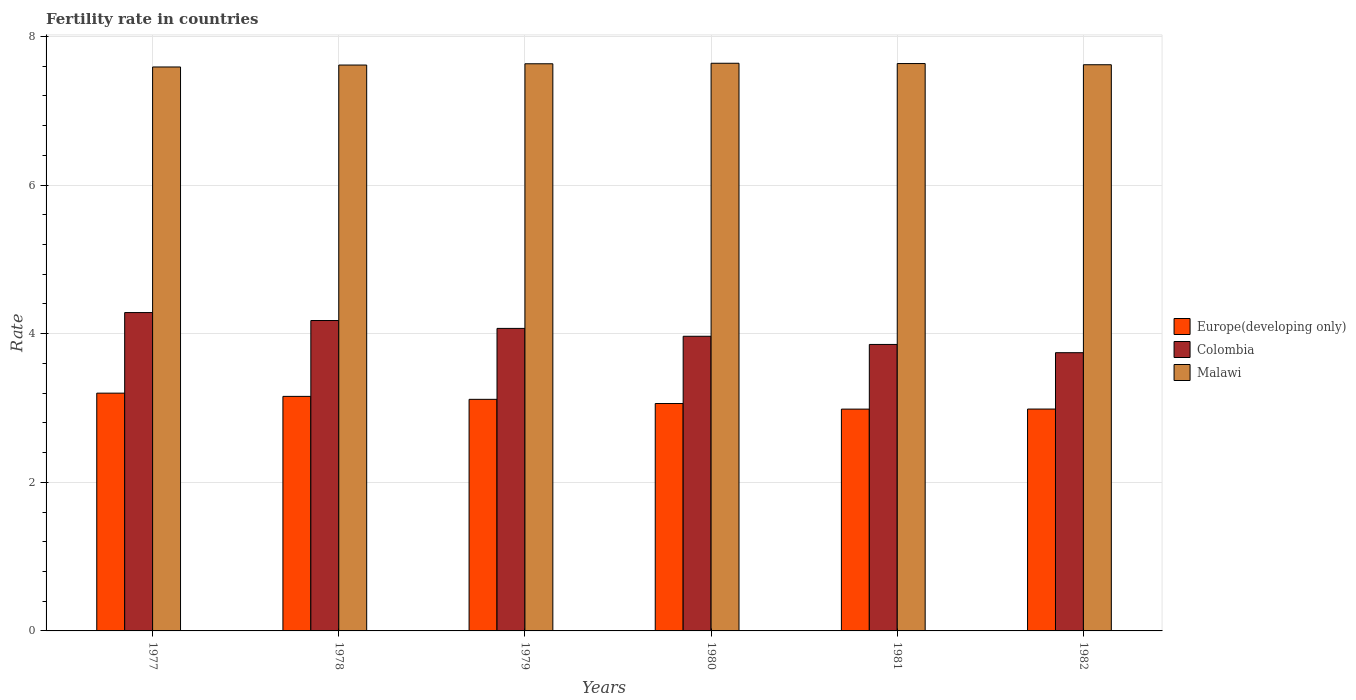Are the number of bars per tick equal to the number of legend labels?
Your answer should be compact. Yes. What is the label of the 3rd group of bars from the left?
Offer a terse response. 1979. What is the fertility rate in Malawi in 1982?
Ensure brevity in your answer.  7.62. Across all years, what is the maximum fertility rate in Europe(developing only)?
Your answer should be compact. 3.2. Across all years, what is the minimum fertility rate in Colombia?
Offer a very short reply. 3.74. In which year was the fertility rate in Europe(developing only) maximum?
Keep it short and to the point. 1977. What is the total fertility rate in Europe(developing only) in the graph?
Keep it short and to the point. 18.5. What is the difference between the fertility rate in Malawi in 1978 and that in 1980?
Keep it short and to the point. -0.02. What is the difference between the fertility rate in Europe(developing only) in 1981 and the fertility rate in Malawi in 1980?
Offer a terse response. -4.65. What is the average fertility rate in Colombia per year?
Your answer should be very brief. 4.02. In the year 1978, what is the difference between the fertility rate in Europe(developing only) and fertility rate in Malawi?
Offer a terse response. -4.46. In how many years, is the fertility rate in Europe(developing only) greater than 7.6?
Make the answer very short. 0. What is the ratio of the fertility rate in Europe(developing only) in 1977 to that in 1981?
Your answer should be very brief. 1.07. Is the fertility rate in Europe(developing only) in 1978 less than that in 1982?
Offer a very short reply. No. Is the difference between the fertility rate in Europe(developing only) in 1977 and 1978 greater than the difference between the fertility rate in Malawi in 1977 and 1978?
Offer a very short reply. Yes. What is the difference between the highest and the second highest fertility rate in Malawi?
Offer a very short reply. 0. What is the difference between the highest and the lowest fertility rate in Colombia?
Provide a short and direct response. 0.54. In how many years, is the fertility rate in Europe(developing only) greater than the average fertility rate in Europe(developing only) taken over all years?
Your answer should be compact. 3. What does the 2nd bar from the right in 1977 represents?
Give a very brief answer. Colombia. Is it the case that in every year, the sum of the fertility rate in Colombia and fertility rate in Europe(developing only) is greater than the fertility rate in Malawi?
Ensure brevity in your answer.  No. What is the difference between two consecutive major ticks on the Y-axis?
Provide a short and direct response. 2. Are the values on the major ticks of Y-axis written in scientific E-notation?
Your answer should be very brief. No. Does the graph contain grids?
Your answer should be very brief. Yes. How many legend labels are there?
Offer a very short reply. 3. How are the legend labels stacked?
Make the answer very short. Vertical. What is the title of the graph?
Ensure brevity in your answer.  Fertility rate in countries. Does "American Samoa" appear as one of the legend labels in the graph?
Offer a terse response. No. What is the label or title of the X-axis?
Provide a succinct answer. Years. What is the label or title of the Y-axis?
Ensure brevity in your answer.  Rate. What is the Rate of Europe(developing only) in 1977?
Your response must be concise. 3.2. What is the Rate in Colombia in 1977?
Provide a short and direct response. 4.28. What is the Rate in Malawi in 1977?
Provide a succinct answer. 7.59. What is the Rate in Europe(developing only) in 1978?
Your answer should be compact. 3.16. What is the Rate of Colombia in 1978?
Offer a very short reply. 4.18. What is the Rate of Malawi in 1978?
Offer a terse response. 7.62. What is the Rate of Europe(developing only) in 1979?
Give a very brief answer. 3.12. What is the Rate in Colombia in 1979?
Make the answer very short. 4.07. What is the Rate of Malawi in 1979?
Your answer should be very brief. 7.63. What is the Rate of Europe(developing only) in 1980?
Offer a terse response. 3.06. What is the Rate of Colombia in 1980?
Offer a very short reply. 3.96. What is the Rate in Malawi in 1980?
Provide a short and direct response. 7.64. What is the Rate of Europe(developing only) in 1981?
Offer a very short reply. 2.98. What is the Rate of Colombia in 1981?
Offer a very short reply. 3.85. What is the Rate of Malawi in 1981?
Your answer should be very brief. 7.63. What is the Rate of Europe(developing only) in 1982?
Your response must be concise. 2.99. What is the Rate in Colombia in 1982?
Make the answer very short. 3.74. What is the Rate in Malawi in 1982?
Give a very brief answer. 7.62. Across all years, what is the maximum Rate of Europe(developing only)?
Offer a terse response. 3.2. Across all years, what is the maximum Rate of Colombia?
Your response must be concise. 4.28. Across all years, what is the maximum Rate in Malawi?
Make the answer very short. 7.64. Across all years, what is the minimum Rate of Europe(developing only)?
Your response must be concise. 2.98. Across all years, what is the minimum Rate in Colombia?
Ensure brevity in your answer.  3.74. Across all years, what is the minimum Rate of Malawi?
Give a very brief answer. 7.59. What is the total Rate of Europe(developing only) in the graph?
Your answer should be compact. 18.5. What is the total Rate in Colombia in the graph?
Ensure brevity in your answer.  24.1. What is the total Rate in Malawi in the graph?
Provide a succinct answer. 45.73. What is the difference between the Rate in Europe(developing only) in 1977 and that in 1978?
Offer a terse response. 0.04. What is the difference between the Rate of Colombia in 1977 and that in 1978?
Offer a very short reply. 0.11. What is the difference between the Rate of Malawi in 1977 and that in 1978?
Offer a terse response. -0.03. What is the difference between the Rate of Europe(developing only) in 1977 and that in 1979?
Ensure brevity in your answer.  0.08. What is the difference between the Rate in Colombia in 1977 and that in 1979?
Keep it short and to the point. 0.21. What is the difference between the Rate of Malawi in 1977 and that in 1979?
Your answer should be compact. -0.04. What is the difference between the Rate of Europe(developing only) in 1977 and that in 1980?
Give a very brief answer. 0.14. What is the difference between the Rate in Colombia in 1977 and that in 1980?
Give a very brief answer. 0.32. What is the difference between the Rate in Europe(developing only) in 1977 and that in 1981?
Your answer should be compact. 0.21. What is the difference between the Rate of Colombia in 1977 and that in 1981?
Keep it short and to the point. 0.43. What is the difference between the Rate in Malawi in 1977 and that in 1981?
Your response must be concise. -0.05. What is the difference between the Rate of Europe(developing only) in 1977 and that in 1982?
Your answer should be very brief. 0.21. What is the difference between the Rate of Colombia in 1977 and that in 1982?
Your response must be concise. 0.54. What is the difference between the Rate in Malawi in 1977 and that in 1982?
Give a very brief answer. -0.03. What is the difference between the Rate of Europe(developing only) in 1978 and that in 1979?
Your answer should be compact. 0.04. What is the difference between the Rate of Colombia in 1978 and that in 1979?
Make the answer very short. 0.11. What is the difference between the Rate of Malawi in 1978 and that in 1979?
Make the answer very short. -0.02. What is the difference between the Rate of Europe(developing only) in 1978 and that in 1980?
Make the answer very short. 0.1. What is the difference between the Rate of Colombia in 1978 and that in 1980?
Provide a short and direct response. 0.21. What is the difference between the Rate of Malawi in 1978 and that in 1980?
Keep it short and to the point. -0.02. What is the difference between the Rate of Europe(developing only) in 1978 and that in 1981?
Offer a terse response. 0.17. What is the difference between the Rate of Colombia in 1978 and that in 1981?
Provide a succinct answer. 0.32. What is the difference between the Rate in Malawi in 1978 and that in 1981?
Offer a very short reply. -0.02. What is the difference between the Rate in Europe(developing only) in 1978 and that in 1982?
Your answer should be compact. 0.17. What is the difference between the Rate of Colombia in 1978 and that in 1982?
Your answer should be compact. 0.43. What is the difference between the Rate of Malawi in 1978 and that in 1982?
Your answer should be compact. -0. What is the difference between the Rate of Europe(developing only) in 1979 and that in 1980?
Your response must be concise. 0.06. What is the difference between the Rate in Colombia in 1979 and that in 1980?
Make the answer very short. 0.11. What is the difference between the Rate in Malawi in 1979 and that in 1980?
Offer a terse response. -0.01. What is the difference between the Rate in Europe(developing only) in 1979 and that in 1981?
Your answer should be compact. 0.13. What is the difference between the Rate in Colombia in 1979 and that in 1981?
Your answer should be compact. 0.22. What is the difference between the Rate of Malawi in 1979 and that in 1981?
Offer a very short reply. -0. What is the difference between the Rate in Europe(developing only) in 1979 and that in 1982?
Your answer should be compact. 0.13. What is the difference between the Rate in Colombia in 1979 and that in 1982?
Your response must be concise. 0.33. What is the difference between the Rate in Malawi in 1979 and that in 1982?
Your response must be concise. 0.01. What is the difference between the Rate of Europe(developing only) in 1980 and that in 1981?
Offer a terse response. 0.08. What is the difference between the Rate in Colombia in 1980 and that in 1981?
Offer a terse response. 0.11. What is the difference between the Rate in Malawi in 1980 and that in 1981?
Give a very brief answer. 0. What is the difference between the Rate in Europe(developing only) in 1980 and that in 1982?
Make the answer very short. 0.07. What is the difference between the Rate of Colombia in 1980 and that in 1982?
Offer a very short reply. 0.22. What is the difference between the Rate in Malawi in 1980 and that in 1982?
Make the answer very short. 0.02. What is the difference between the Rate in Europe(developing only) in 1981 and that in 1982?
Give a very brief answer. -0. What is the difference between the Rate in Colombia in 1981 and that in 1982?
Provide a succinct answer. 0.11. What is the difference between the Rate in Malawi in 1981 and that in 1982?
Your answer should be very brief. 0.02. What is the difference between the Rate of Europe(developing only) in 1977 and the Rate of Colombia in 1978?
Your answer should be compact. -0.98. What is the difference between the Rate in Europe(developing only) in 1977 and the Rate in Malawi in 1978?
Keep it short and to the point. -4.42. What is the difference between the Rate in Colombia in 1977 and the Rate in Malawi in 1978?
Give a very brief answer. -3.33. What is the difference between the Rate in Europe(developing only) in 1977 and the Rate in Colombia in 1979?
Provide a short and direct response. -0.87. What is the difference between the Rate of Europe(developing only) in 1977 and the Rate of Malawi in 1979?
Ensure brevity in your answer.  -4.43. What is the difference between the Rate in Colombia in 1977 and the Rate in Malawi in 1979?
Ensure brevity in your answer.  -3.35. What is the difference between the Rate of Europe(developing only) in 1977 and the Rate of Colombia in 1980?
Offer a very short reply. -0.77. What is the difference between the Rate in Europe(developing only) in 1977 and the Rate in Malawi in 1980?
Your answer should be very brief. -4.44. What is the difference between the Rate in Colombia in 1977 and the Rate in Malawi in 1980?
Keep it short and to the point. -3.35. What is the difference between the Rate in Europe(developing only) in 1977 and the Rate in Colombia in 1981?
Provide a succinct answer. -0.66. What is the difference between the Rate of Europe(developing only) in 1977 and the Rate of Malawi in 1981?
Keep it short and to the point. -4.44. What is the difference between the Rate in Colombia in 1977 and the Rate in Malawi in 1981?
Offer a very short reply. -3.35. What is the difference between the Rate of Europe(developing only) in 1977 and the Rate of Colombia in 1982?
Provide a succinct answer. -0.54. What is the difference between the Rate in Europe(developing only) in 1977 and the Rate in Malawi in 1982?
Offer a terse response. -4.42. What is the difference between the Rate of Colombia in 1977 and the Rate of Malawi in 1982?
Give a very brief answer. -3.33. What is the difference between the Rate in Europe(developing only) in 1978 and the Rate in Colombia in 1979?
Your response must be concise. -0.91. What is the difference between the Rate in Europe(developing only) in 1978 and the Rate in Malawi in 1979?
Give a very brief answer. -4.48. What is the difference between the Rate of Colombia in 1978 and the Rate of Malawi in 1979?
Provide a short and direct response. -3.46. What is the difference between the Rate of Europe(developing only) in 1978 and the Rate of Colombia in 1980?
Offer a terse response. -0.81. What is the difference between the Rate of Europe(developing only) in 1978 and the Rate of Malawi in 1980?
Your response must be concise. -4.48. What is the difference between the Rate in Colombia in 1978 and the Rate in Malawi in 1980?
Keep it short and to the point. -3.46. What is the difference between the Rate in Europe(developing only) in 1978 and the Rate in Colombia in 1981?
Your response must be concise. -0.7. What is the difference between the Rate of Europe(developing only) in 1978 and the Rate of Malawi in 1981?
Offer a very short reply. -4.48. What is the difference between the Rate of Colombia in 1978 and the Rate of Malawi in 1981?
Provide a short and direct response. -3.46. What is the difference between the Rate in Europe(developing only) in 1978 and the Rate in Colombia in 1982?
Offer a terse response. -0.59. What is the difference between the Rate in Europe(developing only) in 1978 and the Rate in Malawi in 1982?
Offer a very short reply. -4.46. What is the difference between the Rate in Colombia in 1978 and the Rate in Malawi in 1982?
Provide a succinct answer. -3.44. What is the difference between the Rate of Europe(developing only) in 1979 and the Rate of Colombia in 1980?
Give a very brief answer. -0.85. What is the difference between the Rate of Europe(developing only) in 1979 and the Rate of Malawi in 1980?
Your answer should be very brief. -4.52. What is the difference between the Rate of Colombia in 1979 and the Rate of Malawi in 1980?
Give a very brief answer. -3.57. What is the difference between the Rate of Europe(developing only) in 1979 and the Rate of Colombia in 1981?
Your response must be concise. -0.74. What is the difference between the Rate in Europe(developing only) in 1979 and the Rate in Malawi in 1981?
Ensure brevity in your answer.  -4.52. What is the difference between the Rate of Colombia in 1979 and the Rate of Malawi in 1981?
Give a very brief answer. -3.56. What is the difference between the Rate in Europe(developing only) in 1979 and the Rate in Colombia in 1982?
Keep it short and to the point. -0.63. What is the difference between the Rate of Europe(developing only) in 1979 and the Rate of Malawi in 1982?
Offer a terse response. -4.5. What is the difference between the Rate in Colombia in 1979 and the Rate in Malawi in 1982?
Keep it short and to the point. -3.55. What is the difference between the Rate of Europe(developing only) in 1980 and the Rate of Colombia in 1981?
Keep it short and to the point. -0.8. What is the difference between the Rate in Europe(developing only) in 1980 and the Rate in Malawi in 1981?
Keep it short and to the point. -4.58. What is the difference between the Rate in Colombia in 1980 and the Rate in Malawi in 1981?
Your response must be concise. -3.67. What is the difference between the Rate of Europe(developing only) in 1980 and the Rate of Colombia in 1982?
Give a very brief answer. -0.68. What is the difference between the Rate in Europe(developing only) in 1980 and the Rate in Malawi in 1982?
Ensure brevity in your answer.  -4.56. What is the difference between the Rate in Colombia in 1980 and the Rate in Malawi in 1982?
Make the answer very short. -3.65. What is the difference between the Rate in Europe(developing only) in 1981 and the Rate in Colombia in 1982?
Provide a short and direct response. -0.76. What is the difference between the Rate in Europe(developing only) in 1981 and the Rate in Malawi in 1982?
Your response must be concise. -4.63. What is the difference between the Rate of Colombia in 1981 and the Rate of Malawi in 1982?
Keep it short and to the point. -3.76. What is the average Rate in Europe(developing only) per year?
Your answer should be compact. 3.08. What is the average Rate of Colombia per year?
Your answer should be very brief. 4.02. What is the average Rate in Malawi per year?
Ensure brevity in your answer.  7.62. In the year 1977, what is the difference between the Rate of Europe(developing only) and Rate of Colombia?
Your answer should be very brief. -1.08. In the year 1977, what is the difference between the Rate of Europe(developing only) and Rate of Malawi?
Give a very brief answer. -4.39. In the year 1977, what is the difference between the Rate in Colombia and Rate in Malawi?
Offer a very short reply. -3.31. In the year 1978, what is the difference between the Rate in Europe(developing only) and Rate in Colombia?
Your answer should be compact. -1.02. In the year 1978, what is the difference between the Rate of Europe(developing only) and Rate of Malawi?
Offer a very short reply. -4.46. In the year 1978, what is the difference between the Rate in Colombia and Rate in Malawi?
Provide a short and direct response. -3.44. In the year 1979, what is the difference between the Rate of Europe(developing only) and Rate of Colombia?
Offer a very short reply. -0.95. In the year 1979, what is the difference between the Rate of Europe(developing only) and Rate of Malawi?
Your answer should be compact. -4.52. In the year 1979, what is the difference between the Rate of Colombia and Rate of Malawi?
Your answer should be compact. -3.56. In the year 1980, what is the difference between the Rate in Europe(developing only) and Rate in Colombia?
Ensure brevity in your answer.  -0.91. In the year 1980, what is the difference between the Rate of Europe(developing only) and Rate of Malawi?
Make the answer very short. -4.58. In the year 1980, what is the difference between the Rate in Colombia and Rate in Malawi?
Ensure brevity in your answer.  -3.67. In the year 1981, what is the difference between the Rate of Europe(developing only) and Rate of Colombia?
Your response must be concise. -0.87. In the year 1981, what is the difference between the Rate of Europe(developing only) and Rate of Malawi?
Offer a terse response. -4.65. In the year 1981, what is the difference between the Rate in Colombia and Rate in Malawi?
Offer a very short reply. -3.78. In the year 1982, what is the difference between the Rate of Europe(developing only) and Rate of Colombia?
Offer a terse response. -0.76. In the year 1982, what is the difference between the Rate of Europe(developing only) and Rate of Malawi?
Ensure brevity in your answer.  -4.63. In the year 1982, what is the difference between the Rate in Colombia and Rate in Malawi?
Give a very brief answer. -3.88. What is the ratio of the Rate in Europe(developing only) in 1977 to that in 1978?
Give a very brief answer. 1.01. What is the ratio of the Rate in Colombia in 1977 to that in 1978?
Your answer should be very brief. 1.03. What is the ratio of the Rate in Malawi in 1977 to that in 1978?
Provide a short and direct response. 1. What is the ratio of the Rate of Europe(developing only) in 1977 to that in 1979?
Provide a succinct answer. 1.03. What is the ratio of the Rate in Colombia in 1977 to that in 1979?
Your response must be concise. 1.05. What is the ratio of the Rate of Europe(developing only) in 1977 to that in 1980?
Your response must be concise. 1.05. What is the ratio of the Rate of Colombia in 1977 to that in 1980?
Provide a succinct answer. 1.08. What is the ratio of the Rate of Europe(developing only) in 1977 to that in 1981?
Your answer should be compact. 1.07. What is the ratio of the Rate in Colombia in 1977 to that in 1981?
Offer a very short reply. 1.11. What is the ratio of the Rate in Malawi in 1977 to that in 1981?
Offer a very short reply. 0.99. What is the ratio of the Rate in Europe(developing only) in 1977 to that in 1982?
Your answer should be compact. 1.07. What is the ratio of the Rate in Colombia in 1977 to that in 1982?
Your response must be concise. 1.14. What is the ratio of the Rate in Malawi in 1977 to that in 1982?
Give a very brief answer. 1. What is the ratio of the Rate of Europe(developing only) in 1978 to that in 1979?
Your answer should be very brief. 1.01. What is the ratio of the Rate of Colombia in 1978 to that in 1979?
Provide a succinct answer. 1.03. What is the ratio of the Rate of Europe(developing only) in 1978 to that in 1980?
Your answer should be very brief. 1.03. What is the ratio of the Rate in Colombia in 1978 to that in 1980?
Your answer should be very brief. 1.05. What is the ratio of the Rate in Malawi in 1978 to that in 1980?
Make the answer very short. 1. What is the ratio of the Rate in Europe(developing only) in 1978 to that in 1981?
Your answer should be compact. 1.06. What is the ratio of the Rate of Colombia in 1978 to that in 1981?
Provide a short and direct response. 1.08. What is the ratio of the Rate of Europe(developing only) in 1978 to that in 1982?
Offer a terse response. 1.06. What is the ratio of the Rate in Colombia in 1978 to that in 1982?
Your response must be concise. 1.12. What is the ratio of the Rate in Europe(developing only) in 1979 to that in 1980?
Offer a very short reply. 1.02. What is the ratio of the Rate of Colombia in 1979 to that in 1980?
Provide a succinct answer. 1.03. What is the ratio of the Rate of Europe(developing only) in 1979 to that in 1981?
Provide a succinct answer. 1.04. What is the ratio of the Rate of Colombia in 1979 to that in 1981?
Your response must be concise. 1.06. What is the ratio of the Rate in Malawi in 1979 to that in 1981?
Ensure brevity in your answer.  1. What is the ratio of the Rate in Europe(developing only) in 1979 to that in 1982?
Provide a short and direct response. 1.04. What is the ratio of the Rate in Colombia in 1979 to that in 1982?
Offer a terse response. 1.09. What is the ratio of the Rate in Malawi in 1979 to that in 1982?
Ensure brevity in your answer.  1. What is the ratio of the Rate in Europe(developing only) in 1980 to that in 1981?
Give a very brief answer. 1.03. What is the ratio of the Rate in Colombia in 1980 to that in 1981?
Provide a succinct answer. 1.03. What is the ratio of the Rate of Europe(developing only) in 1980 to that in 1982?
Keep it short and to the point. 1.02. What is the ratio of the Rate in Colombia in 1980 to that in 1982?
Make the answer very short. 1.06. What is the ratio of the Rate in Malawi in 1980 to that in 1982?
Ensure brevity in your answer.  1. What is the ratio of the Rate in Colombia in 1981 to that in 1982?
Your answer should be very brief. 1.03. What is the ratio of the Rate of Malawi in 1981 to that in 1982?
Ensure brevity in your answer.  1. What is the difference between the highest and the second highest Rate in Europe(developing only)?
Provide a succinct answer. 0.04. What is the difference between the highest and the second highest Rate of Colombia?
Provide a short and direct response. 0.11. What is the difference between the highest and the second highest Rate of Malawi?
Your answer should be very brief. 0. What is the difference between the highest and the lowest Rate of Europe(developing only)?
Ensure brevity in your answer.  0.21. What is the difference between the highest and the lowest Rate in Colombia?
Ensure brevity in your answer.  0.54. What is the difference between the highest and the lowest Rate of Malawi?
Ensure brevity in your answer.  0.05. 